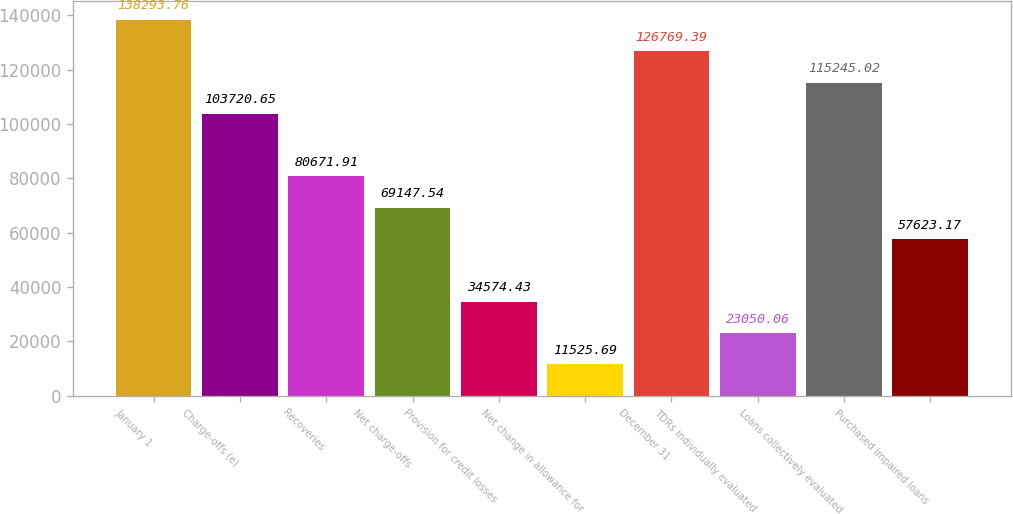Convert chart. <chart><loc_0><loc_0><loc_500><loc_500><bar_chart><fcel>January 1<fcel>Charge-offs (e)<fcel>Recoveries<fcel>Net charge-offs<fcel>Provision for credit losses<fcel>Net change in allowance for<fcel>December 31<fcel>TDRs individually evaluated<fcel>Loans collectively evaluated<fcel>Purchased impaired loans<nl><fcel>138294<fcel>103721<fcel>80671.9<fcel>69147.5<fcel>34574.4<fcel>11525.7<fcel>126769<fcel>23050.1<fcel>115245<fcel>57623.2<nl></chart> 